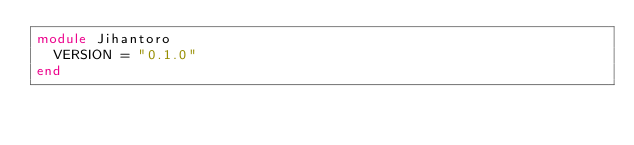Convert code to text. <code><loc_0><loc_0><loc_500><loc_500><_Crystal_>module Jihantoro
  VERSION = "0.1.0"
end
</code> 